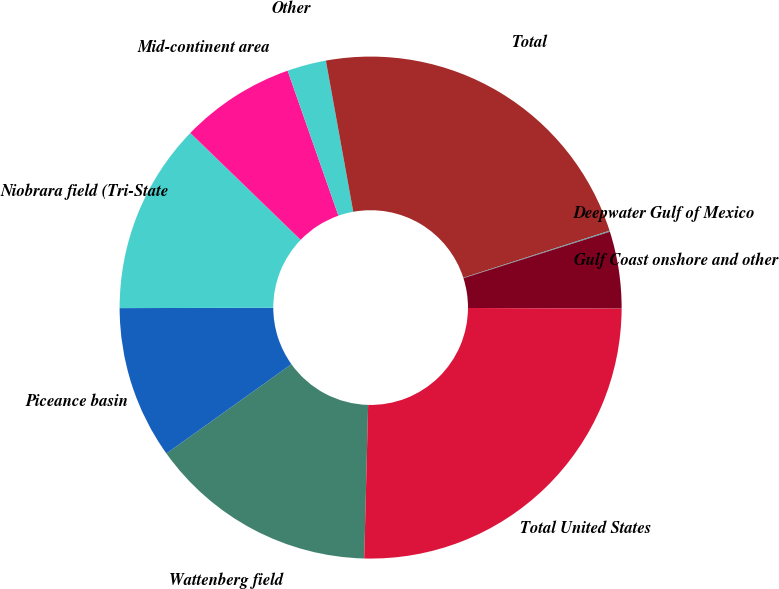Convert chart to OTSL. <chart><loc_0><loc_0><loc_500><loc_500><pie_chart><fcel>Wattenberg field<fcel>Piceance basin<fcel>Niobrara field (Tri-State<fcel>Mid-continent area<fcel>Other<fcel>Total<fcel>Deepwater Gulf of Mexico<fcel>Gulf Coast onshore and other<fcel>Total United States<nl><fcel>14.72%<fcel>9.84%<fcel>12.28%<fcel>7.39%<fcel>2.51%<fcel>22.9%<fcel>0.07%<fcel>4.95%<fcel>25.34%<nl></chart> 